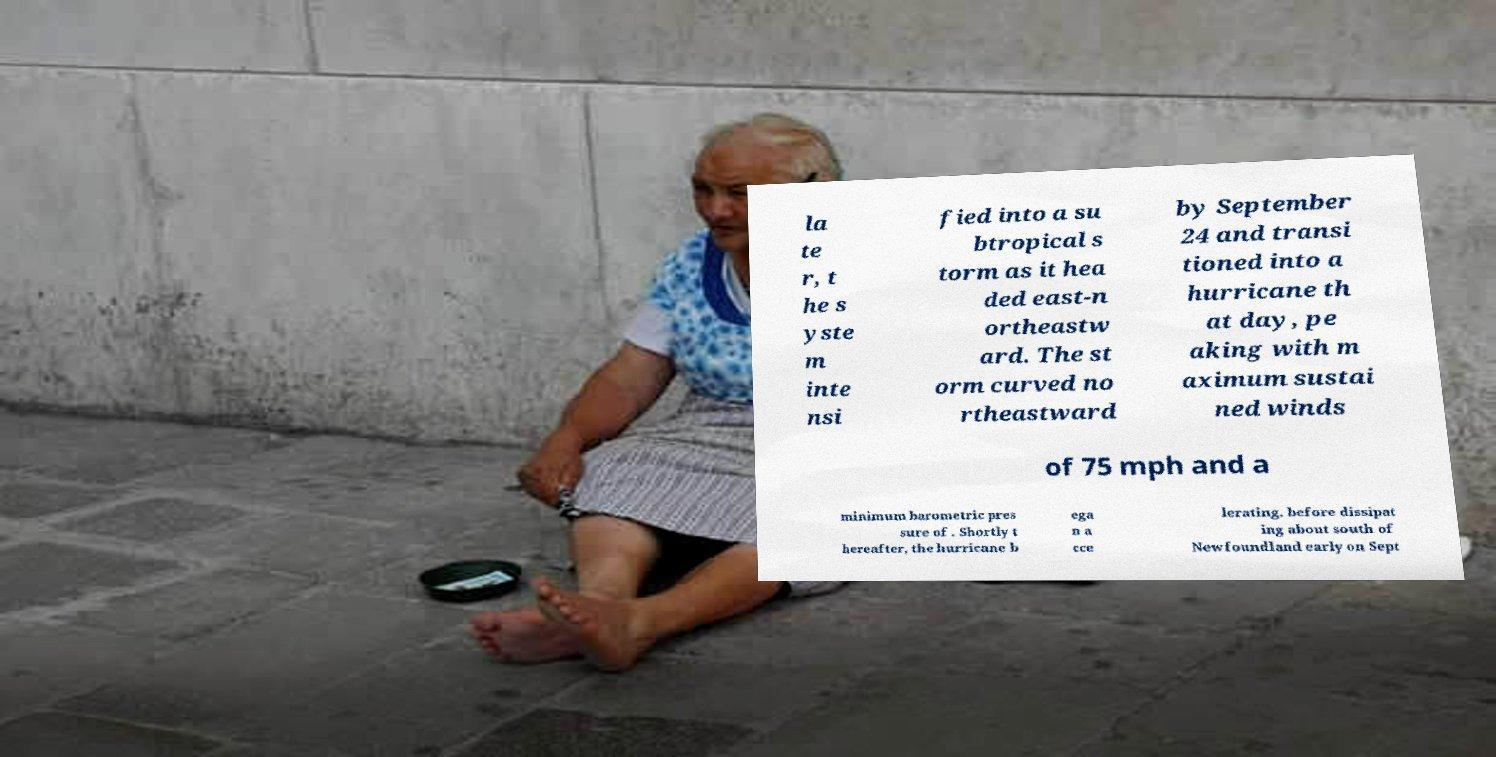Please identify and transcribe the text found in this image. la te r, t he s yste m inte nsi fied into a su btropical s torm as it hea ded east-n ortheastw ard. The st orm curved no rtheastward by September 24 and transi tioned into a hurricane th at day, pe aking with m aximum sustai ned winds of 75 mph and a minimum barometric pres sure of . Shortly t hereafter, the hurricane b ega n a cce lerating, before dissipat ing about south of Newfoundland early on Sept 